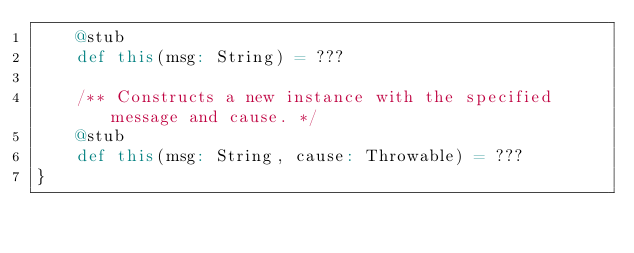<code> <loc_0><loc_0><loc_500><loc_500><_Scala_>    @stub
    def this(msg: String) = ???

    /** Constructs a new instance with the specified message and cause. */
    @stub
    def this(msg: String, cause: Throwable) = ???
}
</code> 